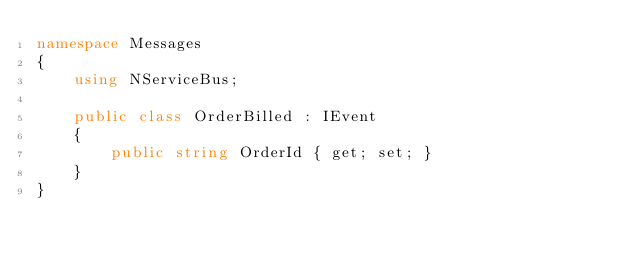<code> <loc_0><loc_0><loc_500><loc_500><_C#_>namespace Messages
{
    using NServiceBus;

    public class OrderBilled : IEvent
    {
        public string OrderId { get; set; }
    }
}</code> 